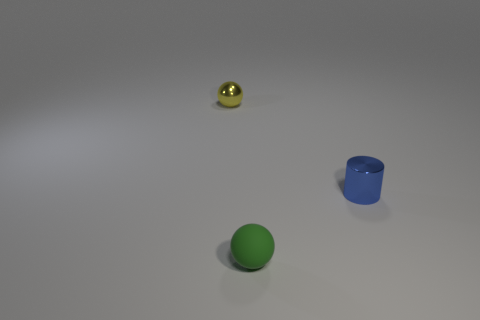Add 3 yellow matte balls. How many objects exist? 6 Subtract all spheres. How many objects are left? 1 Subtract 0 purple blocks. How many objects are left? 3 Subtract all green rubber balls. Subtract all small metal cylinders. How many objects are left? 1 Add 1 green things. How many green things are left? 2 Add 3 balls. How many balls exist? 5 